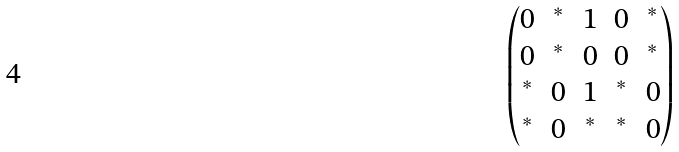Convert formula to latex. <formula><loc_0><loc_0><loc_500><loc_500>\begin{pmatrix} 0 & ^ { * } & 1 & 0 & ^ { * } \\ 0 & ^ { * } & 0 & 0 & ^ { * } \\ ^ { * } & 0 & 1 & ^ { * } & 0 \\ ^ { * } & 0 & ^ { * } & ^ { * } & 0 \end{pmatrix}</formula> 